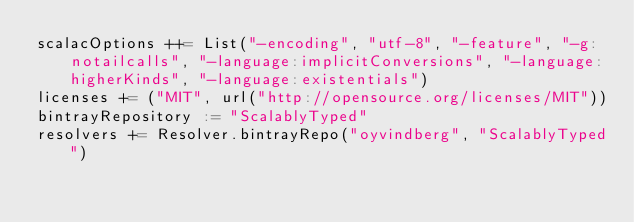Convert code to text. <code><loc_0><loc_0><loc_500><loc_500><_Scala_>scalacOptions ++= List("-encoding", "utf-8", "-feature", "-g:notailcalls", "-language:implicitConversions", "-language:higherKinds", "-language:existentials")
licenses += ("MIT", url("http://opensource.org/licenses/MIT"))
bintrayRepository := "ScalablyTyped"
resolvers += Resolver.bintrayRepo("oyvindberg", "ScalablyTyped")
</code> 